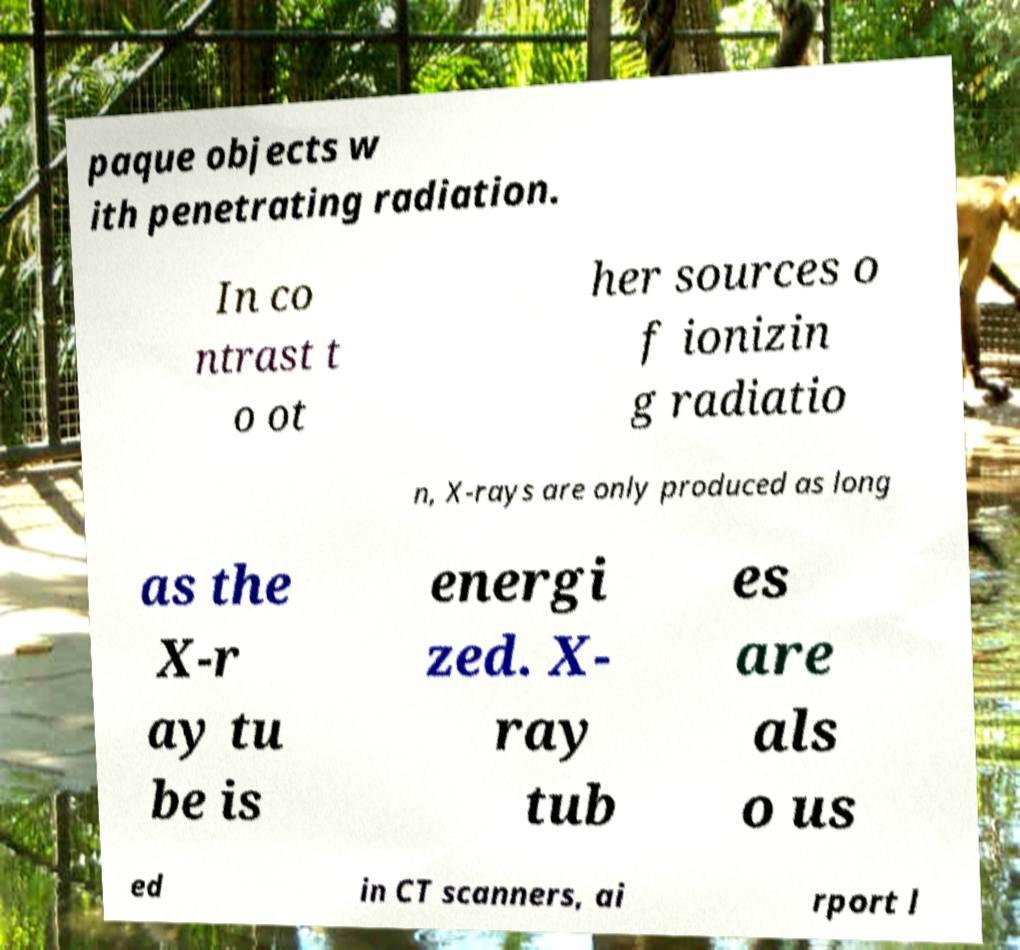Can you accurately transcribe the text from the provided image for me? paque objects w ith penetrating radiation. In co ntrast t o ot her sources o f ionizin g radiatio n, X-rays are only produced as long as the X-r ay tu be is energi zed. X- ray tub es are als o us ed in CT scanners, ai rport l 